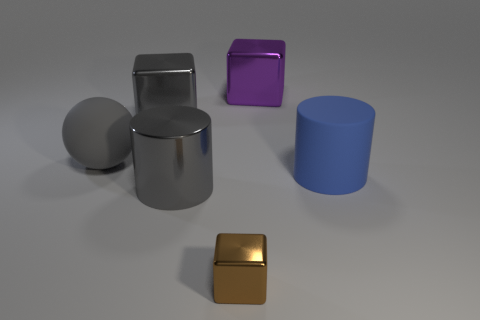Is there anything else that is the same size as the brown metallic cube?
Offer a terse response. No. There is a cylinder that is to the left of the large purple object; what material is it?
Ensure brevity in your answer.  Metal. How big is the gray rubber ball?
Give a very brief answer. Large. How many gray things are either big objects or rubber cylinders?
Ensure brevity in your answer.  3. What is the size of the rubber thing right of the large metallic cube right of the brown object?
Make the answer very short. Large. There is a tiny shiny cube; is its color the same as the large cylinder in front of the blue object?
Provide a short and direct response. No. What number of other objects are there of the same material as the purple thing?
Provide a succinct answer. 3. There is a big blue thing that is the same material as the gray sphere; what shape is it?
Your response must be concise. Cylinder. Are there any other things that have the same color as the small cube?
Provide a succinct answer. No. There is a rubber ball that is the same color as the big shiny cylinder; what is its size?
Offer a very short reply. Large. 